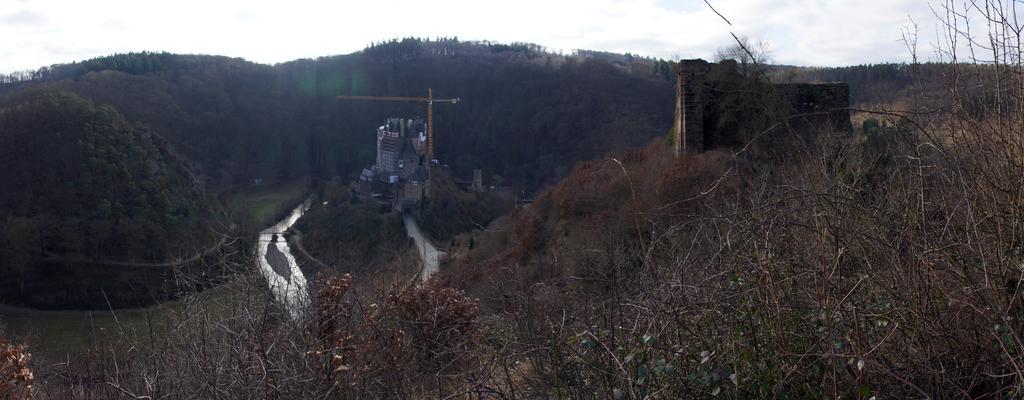Please provide a concise description of this image. On the right side, there are trees and a building on a mountain. In the middle of this image, there are buildings, a road and there are trees on a mountain. Beside this mountain, there is water. On the left side, there are mountains. In the background, there are mountains and there are clouds in the sky. 